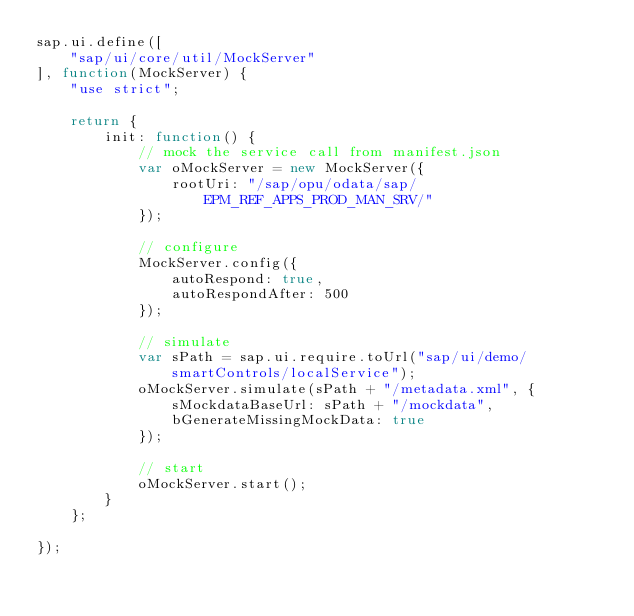Convert code to text. <code><loc_0><loc_0><loc_500><loc_500><_JavaScript_>sap.ui.define([
	"sap/ui/core/util/MockServer"
], function(MockServer) {
	"use strict";

	return {
		init: function() {
			// mock the service call from manifest.json
			var oMockServer = new MockServer({
				rootUri: "/sap/opu/odata/sap/EPM_REF_APPS_PROD_MAN_SRV/"
			});

			// configure
			MockServer.config({
				autoRespond: true,
				autoRespondAfter: 500
			});

			// simulate
			var sPath = sap.ui.require.toUrl("sap/ui/demo/smartControls/localService");
			oMockServer.simulate(sPath + "/metadata.xml", {
				sMockdataBaseUrl: sPath + "/mockdata",
				bGenerateMissingMockData: true
			});

			// start
			oMockServer.start();
		}
	};

});
</code> 